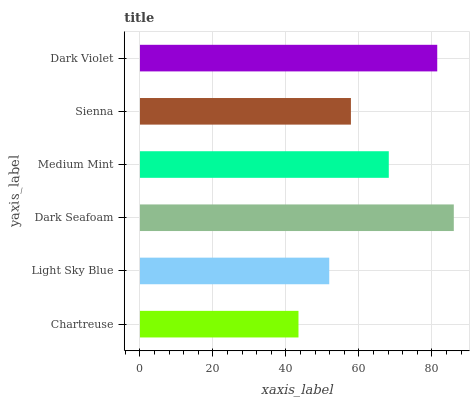Is Chartreuse the minimum?
Answer yes or no. Yes. Is Dark Seafoam the maximum?
Answer yes or no. Yes. Is Light Sky Blue the minimum?
Answer yes or no. No. Is Light Sky Blue the maximum?
Answer yes or no. No. Is Light Sky Blue greater than Chartreuse?
Answer yes or no. Yes. Is Chartreuse less than Light Sky Blue?
Answer yes or no. Yes. Is Chartreuse greater than Light Sky Blue?
Answer yes or no. No. Is Light Sky Blue less than Chartreuse?
Answer yes or no. No. Is Medium Mint the high median?
Answer yes or no. Yes. Is Sienna the low median?
Answer yes or no. Yes. Is Light Sky Blue the high median?
Answer yes or no. No. Is Dark Seafoam the low median?
Answer yes or no. No. 